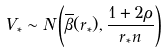Convert formula to latex. <formula><loc_0><loc_0><loc_500><loc_500>V _ { * } \sim N \left ( \overline { \beta } ( r _ { * } ) , \frac { 1 + 2 \rho } { r _ { * } n } \right )</formula> 